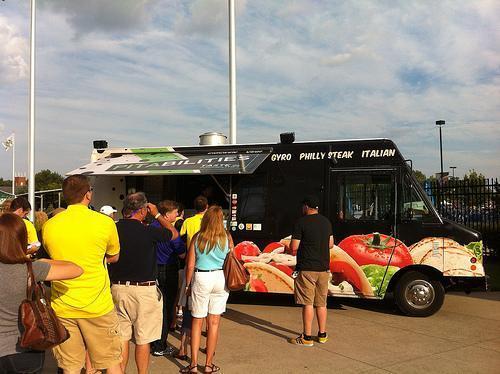How many women in a blue tank top?
Give a very brief answer. 1. 